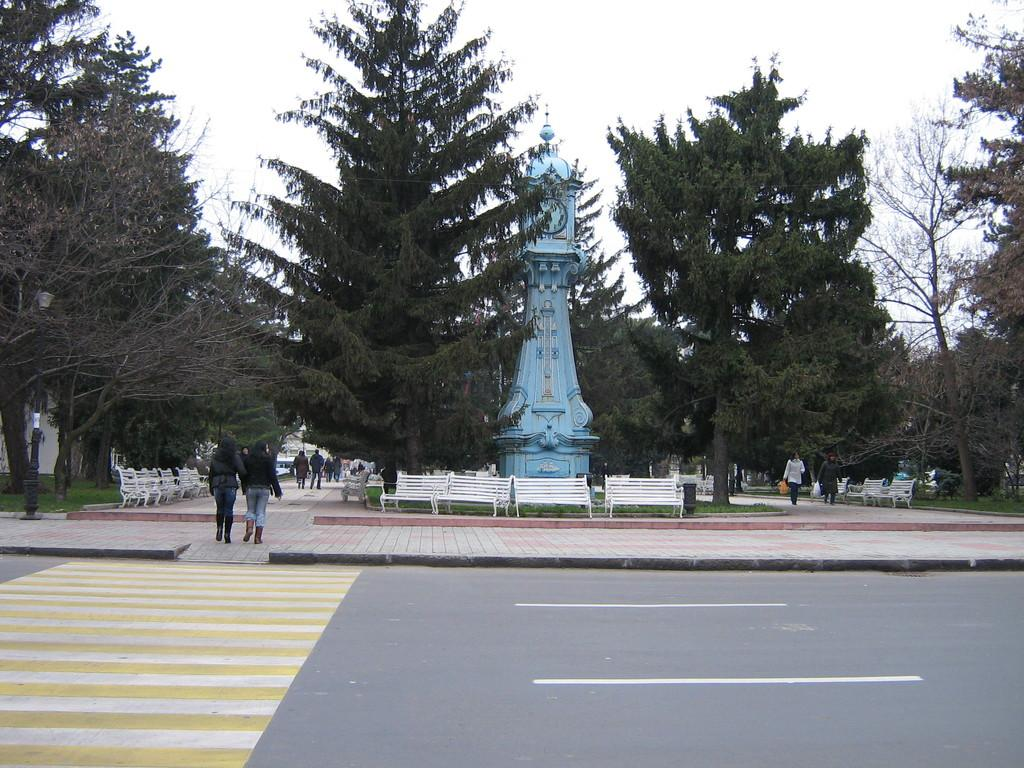What is the main subject of the image? The main subject of the image is a group of people standing. What other elements can be seen in the image besides the people? There are plants, benches, trees, and a clock tower in the image. Can you describe the clock tower in the image? The clock tower has a clock as part of its structure. What is visible in the background of the image? The sky is visible in the background of the image. What type of soup is being served in the image? There is no soup present in the image. Can you tell me how many fingers the girl in the image has? There is no girl present in the image. 